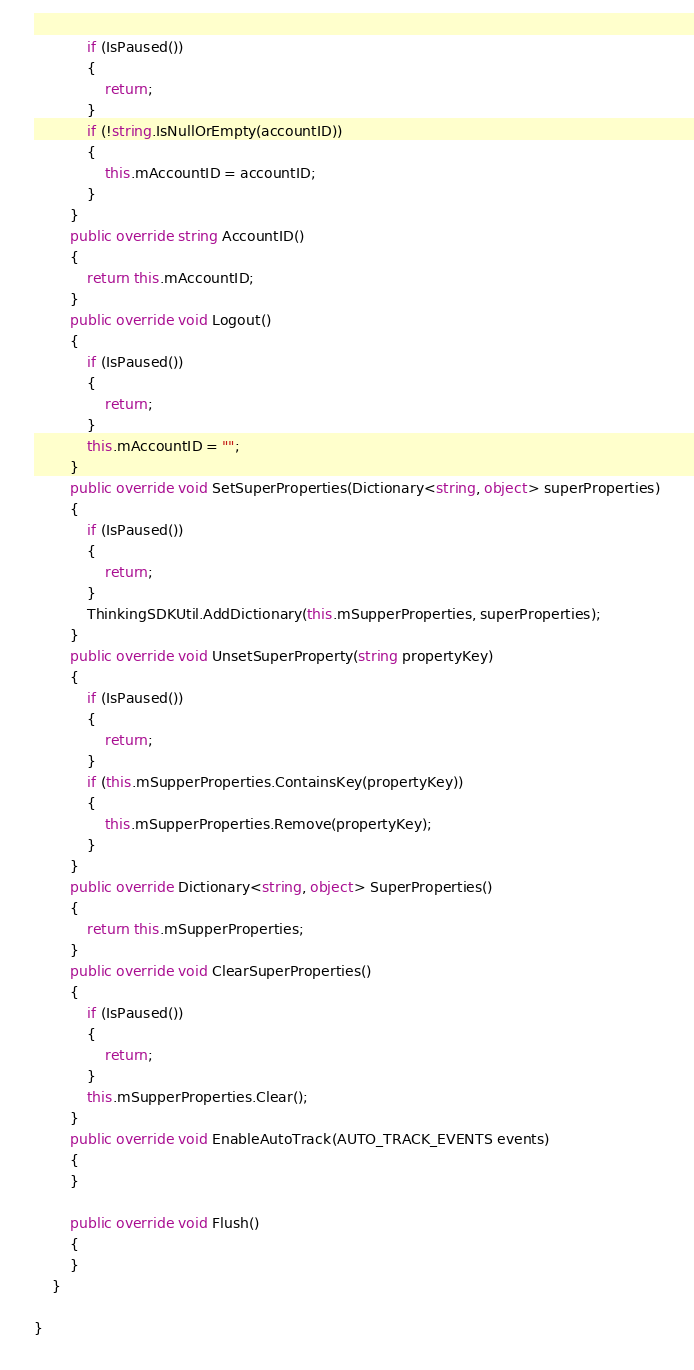<code> <loc_0><loc_0><loc_500><loc_500><_C#_>            if (IsPaused())
            {
                return;
            }
            if (!string.IsNullOrEmpty(accountID))
            {
                this.mAccountID = accountID;
            }
        }
        public override string AccountID()
        {
            return this.mAccountID;
        }
        public override void Logout()
        {
            if (IsPaused())
            {
                return;
            }
            this.mAccountID = "";
        }
        public override void SetSuperProperties(Dictionary<string, object> superProperties)
        {
            if (IsPaused())
            {
                return;
            }
            ThinkingSDKUtil.AddDictionary(this.mSupperProperties, superProperties);
        }
        public override void UnsetSuperProperty(string propertyKey)
        {
            if (IsPaused())
            {
                return;
            }
            if (this.mSupperProperties.ContainsKey(propertyKey))
            {
                this.mSupperProperties.Remove(propertyKey);
            }
        }
        public override Dictionary<string, object> SuperProperties()
        {
            return this.mSupperProperties;
        }
        public override void ClearSuperProperties()
        {
            if (IsPaused())
            {
                return;
            }
            this.mSupperProperties.Clear();
        }
        public override void EnableAutoTrack(AUTO_TRACK_EVENTS events)
        {
        }

        public override void Flush()
        {    
        }
    }

}</code> 